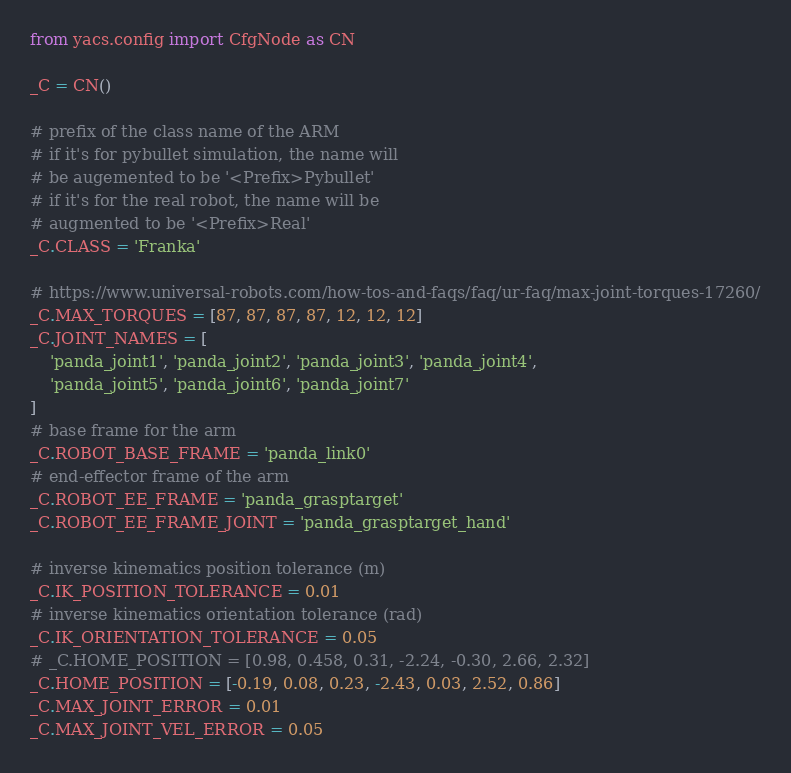<code> <loc_0><loc_0><loc_500><loc_500><_Python_>from yacs.config import CfgNode as CN

_C = CN()

# prefix of the class name of the ARM
# if it's for pybullet simulation, the name will
# be augemented to be '<Prefix>Pybullet'
# if it's for the real robot, the name will be
# augmented to be '<Prefix>Real'
_C.CLASS = 'Franka'

# https://www.universal-robots.com/how-tos-and-faqs/faq/ur-faq/max-joint-torques-17260/
_C.MAX_TORQUES = [87, 87, 87, 87, 12, 12, 12]
_C.JOINT_NAMES = [
    'panda_joint1', 'panda_joint2', 'panda_joint3', 'panda_joint4',
    'panda_joint5', 'panda_joint6', 'panda_joint7'
]
# base frame for the arm
_C.ROBOT_BASE_FRAME = 'panda_link0'
# end-effector frame of the arm
_C.ROBOT_EE_FRAME = 'panda_grasptarget'
_C.ROBOT_EE_FRAME_JOINT = 'panda_grasptarget_hand'

# inverse kinematics position tolerance (m)
_C.IK_POSITION_TOLERANCE = 0.01
# inverse kinematics orientation tolerance (rad)
_C.IK_ORIENTATION_TOLERANCE = 0.05
# _C.HOME_POSITION = [0.98, 0.458, 0.31, -2.24, -0.30, 2.66, 2.32]
_C.HOME_POSITION = [-0.19, 0.08, 0.23, -2.43, 0.03, 2.52, 0.86]
_C.MAX_JOINT_ERROR = 0.01
_C.MAX_JOINT_VEL_ERROR = 0.05</code> 